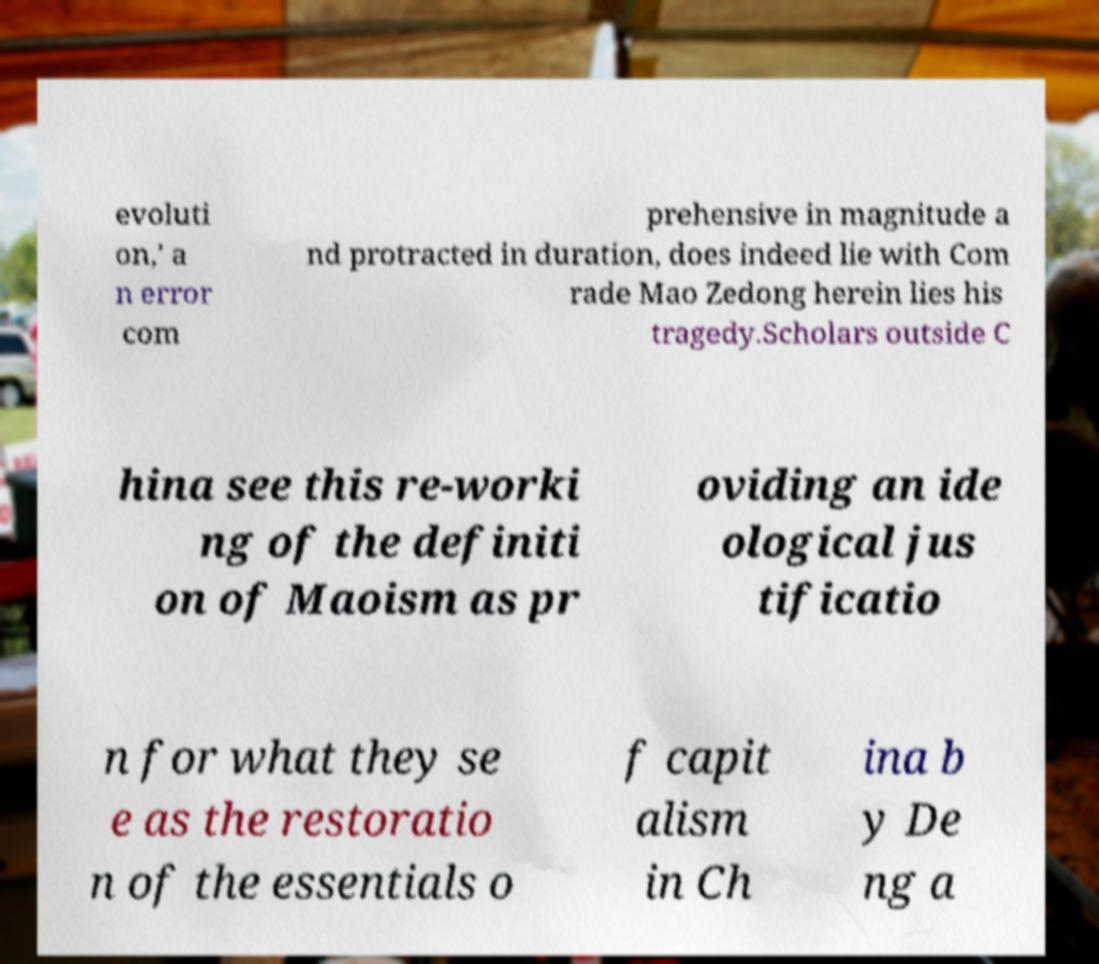For documentation purposes, I need the text within this image transcribed. Could you provide that? evoluti on,' a n error com prehensive in magnitude a nd protracted in duration, does indeed lie with Com rade Mao Zedong herein lies his tragedy.Scholars outside C hina see this re-worki ng of the definiti on of Maoism as pr oviding an ide ological jus tificatio n for what they se e as the restoratio n of the essentials o f capit alism in Ch ina b y De ng a 